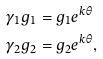Convert formula to latex. <formula><loc_0><loc_0><loc_500><loc_500>\gamma _ { 1 } g _ { 1 } & = g _ { 1 } e ^ { k \theta } \\ \gamma _ { 2 } g _ { 2 } & = g _ { 2 } e ^ { k \theta } ,</formula> 